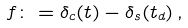<formula> <loc_0><loc_0><loc_500><loc_500>f \colon = { \delta _ { c } ( t ) } - { \delta _ { s } ( t _ { d } ) } \, ,</formula> 